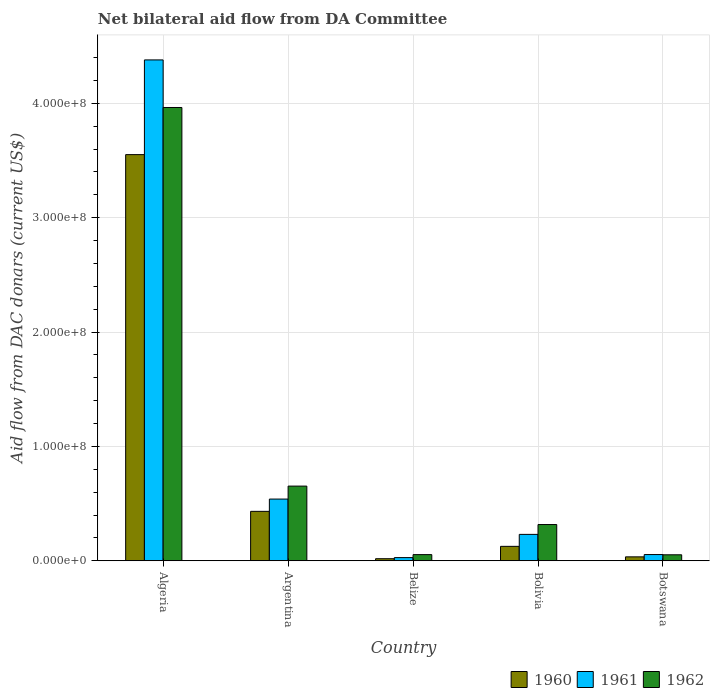How many different coloured bars are there?
Provide a short and direct response. 3. How many groups of bars are there?
Give a very brief answer. 5. Are the number of bars per tick equal to the number of legend labels?
Offer a very short reply. Yes. Are the number of bars on each tick of the X-axis equal?
Your response must be concise. Yes. What is the label of the 4th group of bars from the left?
Provide a short and direct response. Bolivia. In how many cases, is the number of bars for a given country not equal to the number of legend labels?
Keep it short and to the point. 0. What is the aid flow in in 1961 in Argentina?
Your response must be concise. 5.40e+07. Across all countries, what is the maximum aid flow in in 1962?
Make the answer very short. 3.96e+08. Across all countries, what is the minimum aid flow in in 1961?
Provide a short and direct response. 2.78e+06. In which country was the aid flow in in 1961 maximum?
Provide a succinct answer. Algeria. In which country was the aid flow in in 1961 minimum?
Ensure brevity in your answer.  Belize. What is the total aid flow in in 1962 in the graph?
Your answer should be compact. 5.04e+08. What is the difference between the aid flow in in 1962 in Algeria and that in Belize?
Your answer should be very brief. 3.91e+08. What is the difference between the aid flow in in 1962 in Belize and the aid flow in in 1960 in Botswana?
Make the answer very short. 1.96e+06. What is the average aid flow in in 1962 per country?
Keep it short and to the point. 1.01e+08. What is the difference between the aid flow in of/in 1962 and aid flow in of/in 1960 in Argentina?
Your answer should be very brief. 2.21e+07. What is the ratio of the aid flow in in 1960 in Argentina to that in Bolivia?
Offer a very short reply. 3.43. Is the difference between the aid flow in in 1962 in Algeria and Belize greater than the difference between the aid flow in in 1960 in Algeria and Belize?
Your answer should be compact. Yes. What is the difference between the highest and the second highest aid flow in in 1961?
Provide a short and direct response. 3.84e+08. What is the difference between the highest and the lowest aid flow in in 1961?
Offer a terse response. 4.35e+08. Is the sum of the aid flow in in 1960 in Belize and Botswana greater than the maximum aid flow in in 1961 across all countries?
Keep it short and to the point. No. What does the 2nd bar from the left in Bolivia represents?
Your response must be concise. 1961. What does the 2nd bar from the right in Algeria represents?
Make the answer very short. 1961. Is it the case that in every country, the sum of the aid flow in in 1962 and aid flow in in 1961 is greater than the aid flow in in 1960?
Ensure brevity in your answer.  Yes. What is the difference between two consecutive major ticks on the Y-axis?
Keep it short and to the point. 1.00e+08. Are the values on the major ticks of Y-axis written in scientific E-notation?
Provide a short and direct response. Yes. Where does the legend appear in the graph?
Keep it short and to the point. Bottom right. How are the legend labels stacked?
Offer a very short reply. Horizontal. What is the title of the graph?
Your answer should be very brief. Net bilateral aid flow from DA Committee. What is the label or title of the X-axis?
Keep it short and to the point. Country. What is the label or title of the Y-axis?
Provide a succinct answer. Aid flow from DAC donars (current US$). What is the Aid flow from DAC donars (current US$) of 1960 in Algeria?
Your response must be concise. 3.55e+08. What is the Aid flow from DAC donars (current US$) in 1961 in Algeria?
Ensure brevity in your answer.  4.38e+08. What is the Aid flow from DAC donars (current US$) in 1962 in Algeria?
Offer a terse response. 3.96e+08. What is the Aid flow from DAC donars (current US$) of 1960 in Argentina?
Provide a short and direct response. 4.32e+07. What is the Aid flow from DAC donars (current US$) in 1961 in Argentina?
Offer a very short reply. 5.40e+07. What is the Aid flow from DAC donars (current US$) in 1962 in Argentina?
Give a very brief answer. 6.53e+07. What is the Aid flow from DAC donars (current US$) in 1960 in Belize?
Offer a terse response. 1.80e+06. What is the Aid flow from DAC donars (current US$) of 1961 in Belize?
Offer a very short reply. 2.78e+06. What is the Aid flow from DAC donars (current US$) of 1962 in Belize?
Your answer should be compact. 5.39e+06. What is the Aid flow from DAC donars (current US$) of 1960 in Bolivia?
Your answer should be very brief. 1.26e+07. What is the Aid flow from DAC donars (current US$) of 1961 in Bolivia?
Provide a short and direct response. 2.31e+07. What is the Aid flow from DAC donars (current US$) in 1962 in Bolivia?
Your answer should be very brief. 3.17e+07. What is the Aid flow from DAC donars (current US$) of 1960 in Botswana?
Offer a terse response. 3.43e+06. What is the Aid flow from DAC donars (current US$) of 1961 in Botswana?
Provide a succinct answer. 5.44e+06. What is the Aid flow from DAC donars (current US$) of 1962 in Botswana?
Offer a terse response. 5.23e+06. Across all countries, what is the maximum Aid flow from DAC donars (current US$) in 1960?
Your answer should be very brief. 3.55e+08. Across all countries, what is the maximum Aid flow from DAC donars (current US$) of 1961?
Make the answer very short. 4.38e+08. Across all countries, what is the maximum Aid flow from DAC donars (current US$) of 1962?
Make the answer very short. 3.96e+08. Across all countries, what is the minimum Aid flow from DAC donars (current US$) of 1960?
Provide a succinct answer. 1.80e+06. Across all countries, what is the minimum Aid flow from DAC donars (current US$) in 1961?
Your response must be concise. 2.78e+06. Across all countries, what is the minimum Aid flow from DAC donars (current US$) in 1962?
Keep it short and to the point. 5.23e+06. What is the total Aid flow from DAC donars (current US$) of 1960 in the graph?
Give a very brief answer. 4.16e+08. What is the total Aid flow from DAC donars (current US$) in 1961 in the graph?
Make the answer very short. 5.23e+08. What is the total Aid flow from DAC donars (current US$) in 1962 in the graph?
Your answer should be very brief. 5.04e+08. What is the difference between the Aid flow from DAC donars (current US$) in 1960 in Algeria and that in Argentina?
Provide a succinct answer. 3.12e+08. What is the difference between the Aid flow from DAC donars (current US$) in 1961 in Algeria and that in Argentina?
Provide a succinct answer. 3.84e+08. What is the difference between the Aid flow from DAC donars (current US$) of 1962 in Algeria and that in Argentina?
Provide a succinct answer. 3.31e+08. What is the difference between the Aid flow from DAC donars (current US$) of 1960 in Algeria and that in Belize?
Your response must be concise. 3.53e+08. What is the difference between the Aid flow from DAC donars (current US$) in 1961 in Algeria and that in Belize?
Offer a very short reply. 4.35e+08. What is the difference between the Aid flow from DAC donars (current US$) in 1962 in Algeria and that in Belize?
Make the answer very short. 3.91e+08. What is the difference between the Aid flow from DAC donars (current US$) of 1960 in Algeria and that in Bolivia?
Your answer should be compact. 3.42e+08. What is the difference between the Aid flow from DAC donars (current US$) in 1961 in Algeria and that in Bolivia?
Ensure brevity in your answer.  4.15e+08. What is the difference between the Aid flow from DAC donars (current US$) of 1962 in Algeria and that in Bolivia?
Provide a short and direct response. 3.65e+08. What is the difference between the Aid flow from DAC donars (current US$) in 1960 in Algeria and that in Botswana?
Provide a short and direct response. 3.52e+08. What is the difference between the Aid flow from DAC donars (current US$) in 1961 in Algeria and that in Botswana?
Give a very brief answer. 4.32e+08. What is the difference between the Aid flow from DAC donars (current US$) in 1962 in Algeria and that in Botswana?
Make the answer very short. 3.91e+08. What is the difference between the Aid flow from DAC donars (current US$) of 1960 in Argentina and that in Belize?
Offer a terse response. 4.14e+07. What is the difference between the Aid flow from DAC donars (current US$) in 1961 in Argentina and that in Belize?
Offer a very short reply. 5.12e+07. What is the difference between the Aid flow from DAC donars (current US$) of 1962 in Argentina and that in Belize?
Your answer should be very brief. 5.99e+07. What is the difference between the Aid flow from DAC donars (current US$) in 1960 in Argentina and that in Bolivia?
Provide a short and direct response. 3.06e+07. What is the difference between the Aid flow from DAC donars (current US$) in 1961 in Argentina and that in Bolivia?
Ensure brevity in your answer.  3.09e+07. What is the difference between the Aid flow from DAC donars (current US$) in 1962 in Argentina and that in Bolivia?
Provide a short and direct response. 3.36e+07. What is the difference between the Aid flow from DAC donars (current US$) in 1960 in Argentina and that in Botswana?
Your answer should be compact. 3.98e+07. What is the difference between the Aid flow from DAC donars (current US$) of 1961 in Argentina and that in Botswana?
Offer a very short reply. 4.85e+07. What is the difference between the Aid flow from DAC donars (current US$) of 1962 in Argentina and that in Botswana?
Offer a very short reply. 6.01e+07. What is the difference between the Aid flow from DAC donars (current US$) in 1960 in Belize and that in Bolivia?
Provide a short and direct response. -1.08e+07. What is the difference between the Aid flow from DAC donars (current US$) of 1961 in Belize and that in Bolivia?
Provide a short and direct response. -2.03e+07. What is the difference between the Aid flow from DAC donars (current US$) in 1962 in Belize and that in Bolivia?
Offer a terse response. -2.63e+07. What is the difference between the Aid flow from DAC donars (current US$) of 1960 in Belize and that in Botswana?
Keep it short and to the point. -1.63e+06. What is the difference between the Aid flow from DAC donars (current US$) in 1961 in Belize and that in Botswana?
Ensure brevity in your answer.  -2.66e+06. What is the difference between the Aid flow from DAC donars (current US$) of 1960 in Bolivia and that in Botswana?
Your answer should be very brief. 9.18e+06. What is the difference between the Aid flow from DAC donars (current US$) of 1961 in Bolivia and that in Botswana?
Give a very brief answer. 1.76e+07. What is the difference between the Aid flow from DAC donars (current US$) in 1962 in Bolivia and that in Botswana?
Provide a succinct answer. 2.64e+07. What is the difference between the Aid flow from DAC donars (current US$) of 1960 in Algeria and the Aid flow from DAC donars (current US$) of 1961 in Argentina?
Your response must be concise. 3.01e+08. What is the difference between the Aid flow from DAC donars (current US$) in 1960 in Algeria and the Aid flow from DAC donars (current US$) in 1962 in Argentina?
Offer a very short reply. 2.90e+08. What is the difference between the Aid flow from DAC donars (current US$) of 1961 in Algeria and the Aid flow from DAC donars (current US$) of 1962 in Argentina?
Provide a short and direct response. 3.73e+08. What is the difference between the Aid flow from DAC donars (current US$) of 1960 in Algeria and the Aid flow from DAC donars (current US$) of 1961 in Belize?
Provide a succinct answer. 3.52e+08. What is the difference between the Aid flow from DAC donars (current US$) of 1960 in Algeria and the Aid flow from DAC donars (current US$) of 1962 in Belize?
Offer a very short reply. 3.50e+08. What is the difference between the Aid flow from DAC donars (current US$) in 1961 in Algeria and the Aid flow from DAC donars (current US$) in 1962 in Belize?
Ensure brevity in your answer.  4.33e+08. What is the difference between the Aid flow from DAC donars (current US$) in 1960 in Algeria and the Aid flow from DAC donars (current US$) in 1961 in Bolivia?
Offer a very short reply. 3.32e+08. What is the difference between the Aid flow from DAC donars (current US$) of 1960 in Algeria and the Aid flow from DAC donars (current US$) of 1962 in Bolivia?
Your answer should be very brief. 3.23e+08. What is the difference between the Aid flow from DAC donars (current US$) in 1961 in Algeria and the Aid flow from DAC donars (current US$) in 1962 in Bolivia?
Your answer should be compact. 4.06e+08. What is the difference between the Aid flow from DAC donars (current US$) in 1960 in Algeria and the Aid flow from DAC donars (current US$) in 1961 in Botswana?
Provide a short and direct response. 3.50e+08. What is the difference between the Aid flow from DAC donars (current US$) in 1960 in Algeria and the Aid flow from DAC donars (current US$) in 1962 in Botswana?
Provide a succinct answer. 3.50e+08. What is the difference between the Aid flow from DAC donars (current US$) in 1961 in Algeria and the Aid flow from DAC donars (current US$) in 1962 in Botswana?
Ensure brevity in your answer.  4.33e+08. What is the difference between the Aid flow from DAC donars (current US$) of 1960 in Argentina and the Aid flow from DAC donars (current US$) of 1961 in Belize?
Your response must be concise. 4.04e+07. What is the difference between the Aid flow from DAC donars (current US$) in 1960 in Argentina and the Aid flow from DAC donars (current US$) in 1962 in Belize?
Offer a terse response. 3.78e+07. What is the difference between the Aid flow from DAC donars (current US$) of 1961 in Argentina and the Aid flow from DAC donars (current US$) of 1962 in Belize?
Offer a very short reply. 4.86e+07. What is the difference between the Aid flow from DAC donars (current US$) of 1960 in Argentina and the Aid flow from DAC donars (current US$) of 1961 in Bolivia?
Offer a terse response. 2.01e+07. What is the difference between the Aid flow from DAC donars (current US$) of 1960 in Argentina and the Aid flow from DAC donars (current US$) of 1962 in Bolivia?
Ensure brevity in your answer.  1.15e+07. What is the difference between the Aid flow from DAC donars (current US$) in 1961 in Argentina and the Aid flow from DAC donars (current US$) in 1962 in Bolivia?
Provide a short and direct response. 2.23e+07. What is the difference between the Aid flow from DAC donars (current US$) in 1960 in Argentina and the Aid flow from DAC donars (current US$) in 1961 in Botswana?
Keep it short and to the point. 3.78e+07. What is the difference between the Aid flow from DAC donars (current US$) of 1960 in Argentina and the Aid flow from DAC donars (current US$) of 1962 in Botswana?
Your answer should be very brief. 3.80e+07. What is the difference between the Aid flow from DAC donars (current US$) in 1961 in Argentina and the Aid flow from DAC donars (current US$) in 1962 in Botswana?
Offer a terse response. 4.87e+07. What is the difference between the Aid flow from DAC donars (current US$) of 1960 in Belize and the Aid flow from DAC donars (current US$) of 1961 in Bolivia?
Keep it short and to the point. -2.13e+07. What is the difference between the Aid flow from DAC donars (current US$) in 1960 in Belize and the Aid flow from DAC donars (current US$) in 1962 in Bolivia?
Provide a short and direct response. -2.99e+07. What is the difference between the Aid flow from DAC donars (current US$) of 1961 in Belize and the Aid flow from DAC donars (current US$) of 1962 in Bolivia?
Your response must be concise. -2.89e+07. What is the difference between the Aid flow from DAC donars (current US$) in 1960 in Belize and the Aid flow from DAC donars (current US$) in 1961 in Botswana?
Your response must be concise. -3.64e+06. What is the difference between the Aid flow from DAC donars (current US$) in 1960 in Belize and the Aid flow from DAC donars (current US$) in 1962 in Botswana?
Keep it short and to the point. -3.43e+06. What is the difference between the Aid flow from DAC donars (current US$) of 1961 in Belize and the Aid flow from DAC donars (current US$) of 1962 in Botswana?
Your answer should be compact. -2.45e+06. What is the difference between the Aid flow from DAC donars (current US$) of 1960 in Bolivia and the Aid flow from DAC donars (current US$) of 1961 in Botswana?
Ensure brevity in your answer.  7.17e+06. What is the difference between the Aid flow from DAC donars (current US$) in 1960 in Bolivia and the Aid flow from DAC donars (current US$) in 1962 in Botswana?
Your response must be concise. 7.38e+06. What is the difference between the Aid flow from DAC donars (current US$) of 1961 in Bolivia and the Aid flow from DAC donars (current US$) of 1962 in Botswana?
Provide a succinct answer. 1.78e+07. What is the average Aid flow from DAC donars (current US$) in 1960 per country?
Give a very brief answer. 8.32e+07. What is the average Aid flow from DAC donars (current US$) in 1961 per country?
Your answer should be compact. 1.05e+08. What is the average Aid flow from DAC donars (current US$) in 1962 per country?
Offer a very short reply. 1.01e+08. What is the difference between the Aid flow from DAC donars (current US$) in 1960 and Aid flow from DAC donars (current US$) in 1961 in Algeria?
Your response must be concise. -8.28e+07. What is the difference between the Aid flow from DAC donars (current US$) of 1960 and Aid flow from DAC donars (current US$) of 1962 in Algeria?
Offer a terse response. -4.12e+07. What is the difference between the Aid flow from DAC donars (current US$) of 1961 and Aid flow from DAC donars (current US$) of 1962 in Algeria?
Ensure brevity in your answer.  4.16e+07. What is the difference between the Aid flow from DAC donars (current US$) of 1960 and Aid flow from DAC donars (current US$) of 1961 in Argentina?
Provide a short and direct response. -1.07e+07. What is the difference between the Aid flow from DAC donars (current US$) of 1960 and Aid flow from DAC donars (current US$) of 1962 in Argentina?
Provide a succinct answer. -2.21e+07. What is the difference between the Aid flow from DAC donars (current US$) in 1961 and Aid flow from DAC donars (current US$) in 1962 in Argentina?
Keep it short and to the point. -1.13e+07. What is the difference between the Aid flow from DAC donars (current US$) in 1960 and Aid flow from DAC donars (current US$) in 1961 in Belize?
Make the answer very short. -9.80e+05. What is the difference between the Aid flow from DAC donars (current US$) in 1960 and Aid flow from DAC donars (current US$) in 1962 in Belize?
Ensure brevity in your answer.  -3.59e+06. What is the difference between the Aid flow from DAC donars (current US$) of 1961 and Aid flow from DAC donars (current US$) of 1962 in Belize?
Keep it short and to the point. -2.61e+06. What is the difference between the Aid flow from DAC donars (current US$) of 1960 and Aid flow from DAC donars (current US$) of 1961 in Bolivia?
Offer a terse response. -1.05e+07. What is the difference between the Aid flow from DAC donars (current US$) of 1960 and Aid flow from DAC donars (current US$) of 1962 in Bolivia?
Provide a short and direct response. -1.91e+07. What is the difference between the Aid flow from DAC donars (current US$) in 1961 and Aid flow from DAC donars (current US$) in 1962 in Bolivia?
Your response must be concise. -8.60e+06. What is the difference between the Aid flow from DAC donars (current US$) of 1960 and Aid flow from DAC donars (current US$) of 1961 in Botswana?
Your answer should be very brief. -2.01e+06. What is the difference between the Aid flow from DAC donars (current US$) in 1960 and Aid flow from DAC donars (current US$) in 1962 in Botswana?
Offer a very short reply. -1.80e+06. What is the difference between the Aid flow from DAC donars (current US$) in 1961 and Aid flow from DAC donars (current US$) in 1962 in Botswana?
Provide a short and direct response. 2.10e+05. What is the ratio of the Aid flow from DAC donars (current US$) of 1960 in Algeria to that in Argentina?
Your answer should be compact. 8.22. What is the ratio of the Aid flow from DAC donars (current US$) of 1961 in Algeria to that in Argentina?
Ensure brevity in your answer.  8.12. What is the ratio of the Aid flow from DAC donars (current US$) in 1962 in Algeria to that in Argentina?
Your answer should be very brief. 6.07. What is the ratio of the Aid flow from DAC donars (current US$) of 1960 in Algeria to that in Belize?
Your response must be concise. 197.28. What is the ratio of the Aid flow from DAC donars (current US$) of 1961 in Algeria to that in Belize?
Ensure brevity in your answer.  157.52. What is the ratio of the Aid flow from DAC donars (current US$) of 1962 in Algeria to that in Belize?
Your answer should be compact. 73.53. What is the ratio of the Aid flow from DAC donars (current US$) of 1960 in Algeria to that in Bolivia?
Your answer should be compact. 28.16. What is the ratio of the Aid flow from DAC donars (current US$) of 1961 in Algeria to that in Bolivia?
Your answer should be compact. 18.97. What is the ratio of the Aid flow from DAC donars (current US$) in 1962 in Algeria to that in Bolivia?
Offer a very short reply. 12.51. What is the ratio of the Aid flow from DAC donars (current US$) in 1960 in Algeria to that in Botswana?
Your answer should be very brief. 103.53. What is the ratio of the Aid flow from DAC donars (current US$) in 1961 in Algeria to that in Botswana?
Keep it short and to the point. 80.5. What is the ratio of the Aid flow from DAC donars (current US$) in 1962 in Algeria to that in Botswana?
Make the answer very short. 75.78. What is the ratio of the Aid flow from DAC donars (current US$) in 1960 in Argentina to that in Belize?
Offer a terse response. 24.01. What is the ratio of the Aid flow from DAC donars (current US$) in 1961 in Argentina to that in Belize?
Provide a short and direct response. 19.41. What is the ratio of the Aid flow from DAC donars (current US$) in 1962 in Argentina to that in Belize?
Make the answer very short. 12.11. What is the ratio of the Aid flow from DAC donars (current US$) in 1960 in Argentina to that in Bolivia?
Your answer should be very brief. 3.43. What is the ratio of the Aid flow from DAC donars (current US$) of 1961 in Argentina to that in Bolivia?
Keep it short and to the point. 2.34. What is the ratio of the Aid flow from DAC donars (current US$) in 1962 in Argentina to that in Bolivia?
Provide a short and direct response. 2.06. What is the ratio of the Aid flow from DAC donars (current US$) of 1960 in Argentina to that in Botswana?
Offer a very short reply. 12.6. What is the ratio of the Aid flow from DAC donars (current US$) in 1961 in Argentina to that in Botswana?
Provide a succinct answer. 9.92. What is the ratio of the Aid flow from DAC donars (current US$) in 1962 in Argentina to that in Botswana?
Provide a short and direct response. 12.48. What is the ratio of the Aid flow from DAC donars (current US$) of 1960 in Belize to that in Bolivia?
Your answer should be very brief. 0.14. What is the ratio of the Aid flow from DAC donars (current US$) of 1961 in Belize to that in Bolivia?
Provide a short and direct response. 0.12. What is the ratio of the Aid flow from DAC donars (current US$) in 1962 in Belize to that in Bolivia?
Make the answer very short. 0.17. What is the ratio of the Aid flow from DAC donars (current US$) of 1960 in Belize to that in Botswana?
Ensure brevity in your answer.  0.52. What is the ratio of the Aid flow from DAC donars (current US$) in 1961 in Belize to that in Botswana?
Offer a very short reply. 0.51. What is the ratio of the Aid flow from DAC donars (current US$) of 1962 in Belize to that in Botswana?
Ensure brevity in your answer.  1.03. What is the ratio of the Aid flow from DAC donars (current US$) in 1960 in Bolivia to that in Botswana?
Make the answer very short. 3.68. What is the ratio of the Aid flow from DAC donars (current US$) of 1961 in Bolivia to that in Botswana?
Your answer should be very brief. 4.24. What is the ratio of the Aid flow from DAC donars (current US$) of 1962 in Bolivia to that in Botswana?
Provide a succinct answer. 6.06. What is the difference between the highest and the second highest Aid flow from DAC donars (current US$) in 1960?
Your answer should be very brief. 3.12e+08. What is the difference between the highest and the second highest Aid flow from DAC donars (current US$) in 1961?
Keep it short and to the point. 3.84e+08. What is the difference between the highest and the second highest Aid flow from DAC donars (current US$) of 1962?
Your response must be concise. 3.31e+08. What is the difference between the highest and the lowest Aid flow from DAC donars (current US$) of 1960?
Keep it short and to the point. 3.53e+08. What is the difference between the highest and the lowest Aid flow from DAC donars (current US$) in 1961?
Keep it short and to the point. 4.35e+08. What is the difference between the highest and the lowest Aid flow from DAC donars (current US$) in 1962?
Give a very brief answer. 3.91e+08. 